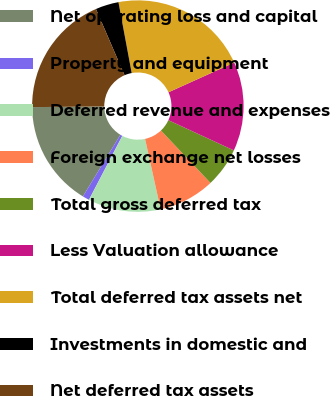Convert chart to OTSL. <chart><loc_0><loc_0><loc_500><loc_500><pie_chart><fcel>Net operating loss and capital<fcel>Property and equipment<fcel>Deferred revenue and expenses<fcel>Foreign exchange net losses<fcel>Total gross deferred tax<fcel>Less Valuation allowance<fcel>Total deferred tax assets net<fcel>Investments in domestic and<fcel>Net deferred tax assets<nl><fcel>16.15%<fcel>1.04%<fcel>11.11%<fcel>8.59%<fcel>6.07%<fcel>13.63%<fcel>21.19%<fcel>3.55%<fcel>18.67%<nl></chart> 